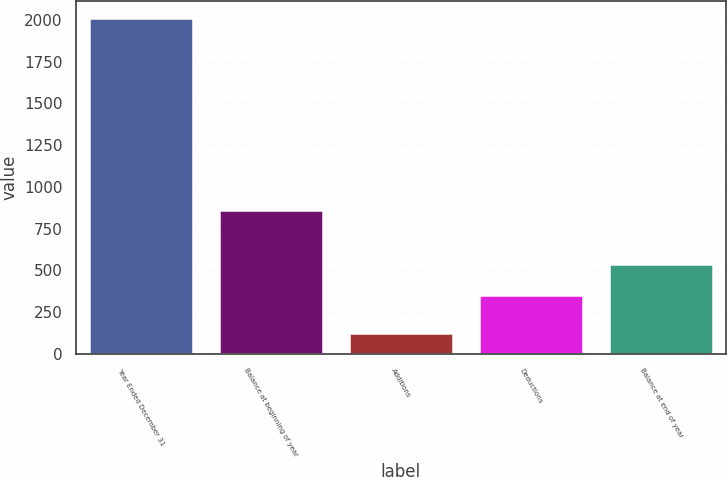Convert chart to OTSL. <chart><loc_0><loc_0><loc_500><loc_500><bar_chart><fcel>Year Ended December 31<fcel>Balance at beginning of year<fcel>Additions<fcel>Deductions<fcel>Balance at end of year<nl><fcel>2012<fcel>859<fcel>126<fcel>352<fcel>540.6<nl></chart> 